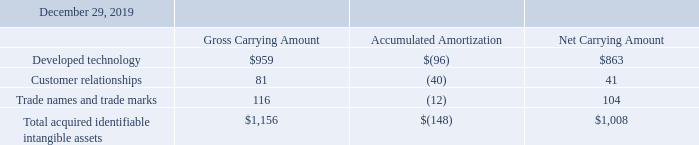6-INTANGIBLE ASSETS
The following table provides the details of the carrying value of intangible assets recorded from the acquisition of SensiML during the year ended December 29, 2019 (in thousands):
What are the respective gross and net carrying amount of developed technology?
Answer scale should be: thousand. $959, $863. What are the respective gross and net carrying amount of customer relationships?
Answer scale should be: thousand. 81, 41. What are the respective gross and net carrying amount of trade names and trade marks?
Answer scale should be: thousand. 116, 104. What is the value of the net carrying amount of the developed technology as a percentage of the gross carrying amount?
Answer scale should be: percent. 863/959 
Answer: 89.99. What is the value of the net carrying amount of customer relationships as a percentage of the gross carrying amount?
Answer scale should be: percent. 41/81 
Answer: 50.62. What is the value of the net carrying amount of trade names and trade marks as a percentage of the gross carrying amount?
Answer scale should be: percent. 104/116 
Answer: 89.66. 